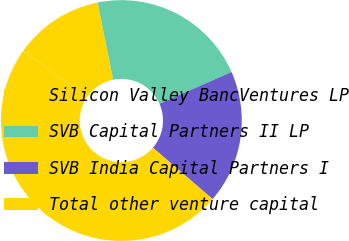<chart> <loc_0><loc_0><loc_500><loc_500><pie_chart><fcel>Silicon Valley BancVentures LP<fcel>SVB Capital Partners II LP<fcel>SVB India Capital Partners I<fcel>Total other venture capital<nl><fcel>12.06%<fcel>21.56%<fcel>17.92%<fcel>48.47%<nl></chart> 